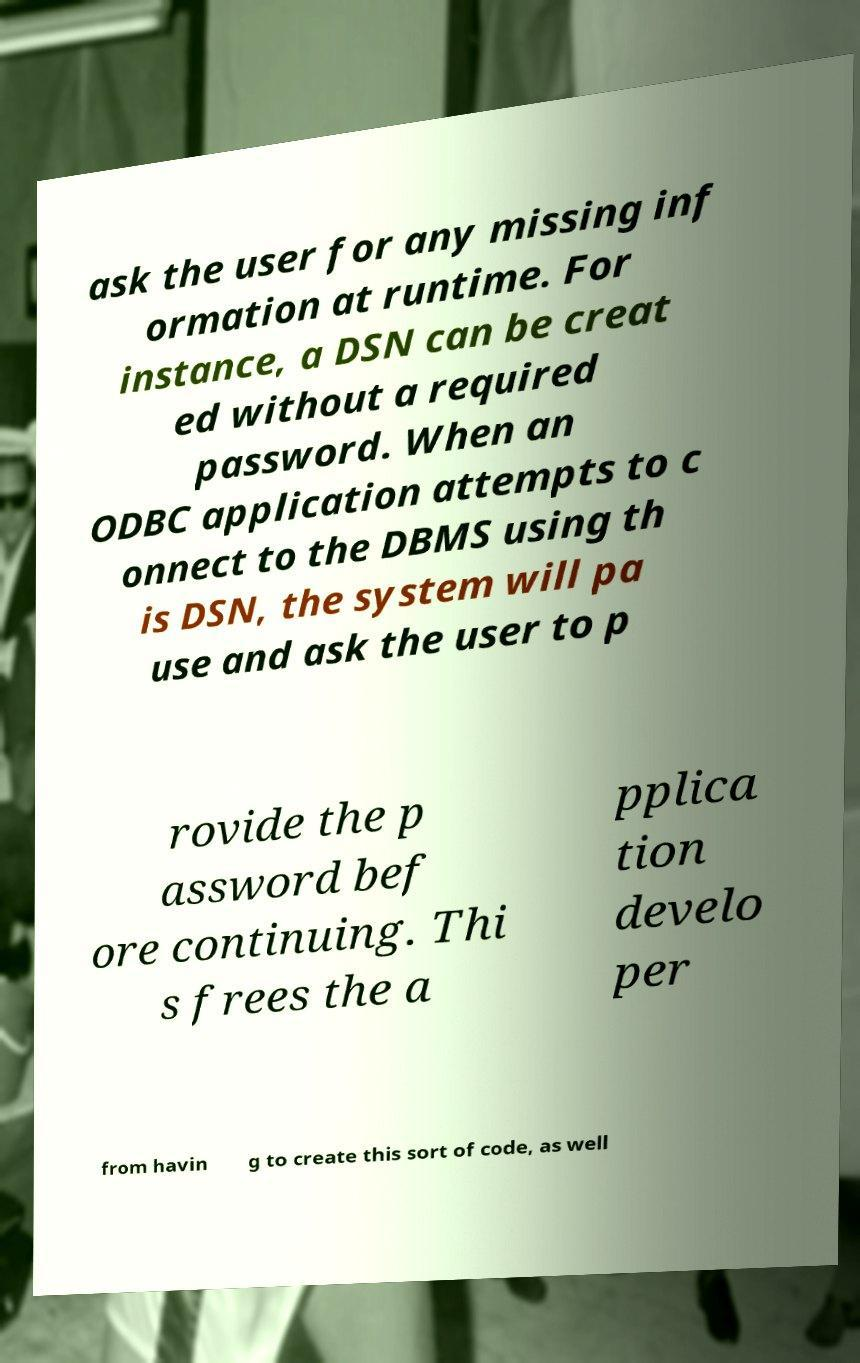Please read and relay the text visible in this image. What does it say? ask the user for any missing inf ormation at runtime. For instance, a DSN can be creat ed without a required password. When an ODBC application attempts to c onnect to the DBMS using th is DSN, the system will pa use and ask the user to p rovide the p assword bef ore continuing. Thi s frees the a pplica tion develo per from havin g to create this sort of code, as well 